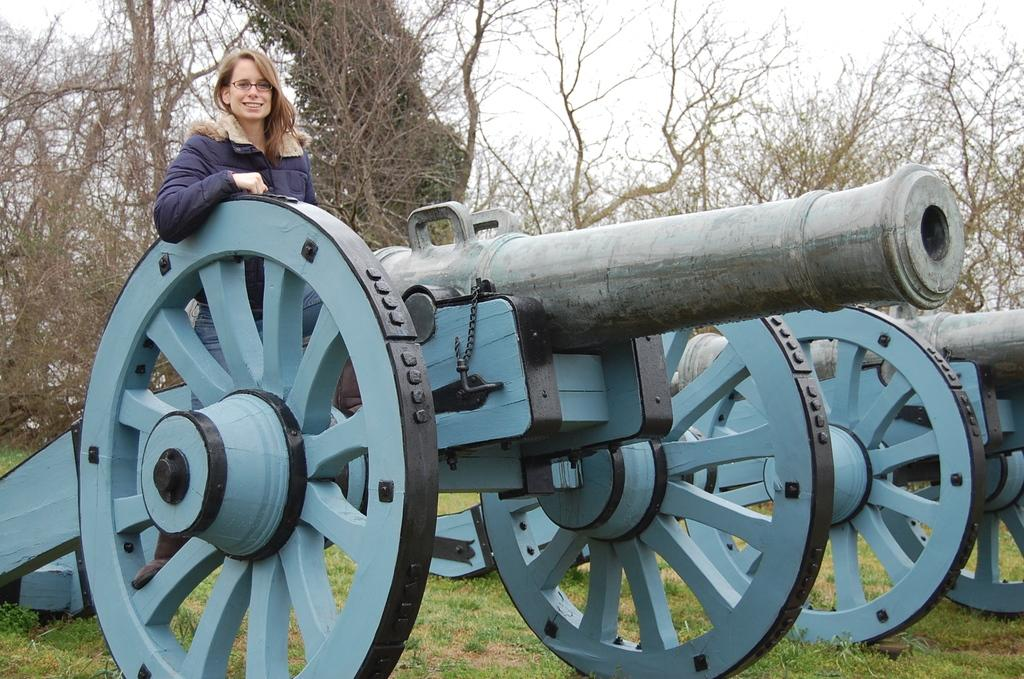What objects are on the grass in the image? There are cannons on the grass in the image. What is the woman doing on one of the cannons? The woman is sitting on one of the cannons. What can be seen on the woman's face in the image? The woman is smiling in the image. What is visible in the background of the image? There are trees and the sky visible in the background of the image. What type of pot is the woman holding in the image? There is no pot present in the image; the woman is sitting on a cannon and not holding anything. Can you tell me how many rats are visible in the image? There are no rats visible in the image. 